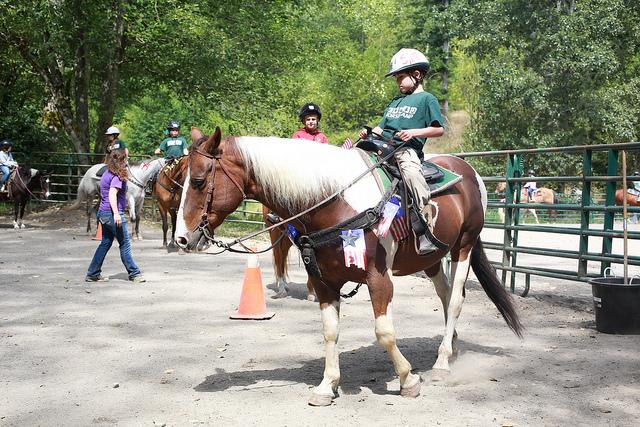Is the boy in front an experienced rider?
Give a very brief answer. No. What are these people doing?
Quick response, please. Riding horses. Is the instructor trained to teach kids to ride horses?
Quick response, please. Yes. 